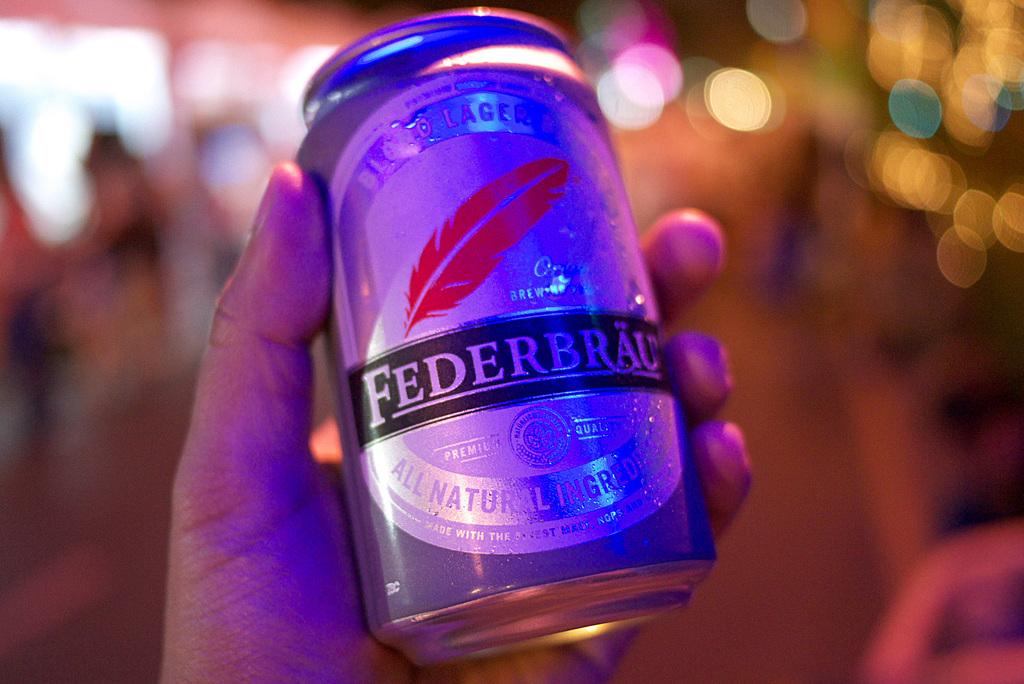What kind of ingredients were used in the brewing process?
Ensure brevity in your answer.  All natural. What is the name of the beer?
Your response must be concise. Federbrau. 